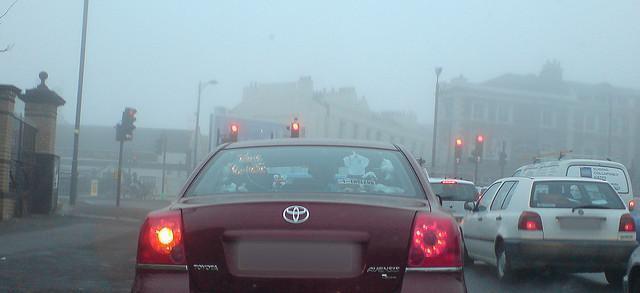Why are the license plates invisible?
From the following four choices, select the correct answer to address the question.
Options: Blurred, on front, new cars, stolen. Blurred. 